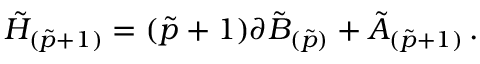Convert formula to latex. <formula><loc_0><loc_0><loc_500><loc_500>\tilde { H } _ { ( \tilde { p } + 1 ) } = ( \tilde { p } + 1 ) \partial \tilde { B } _ { ( \tilde { p } ) } + \tilde { A } _ { ( \tilde { p } + 1 ) } \, .</formula> 